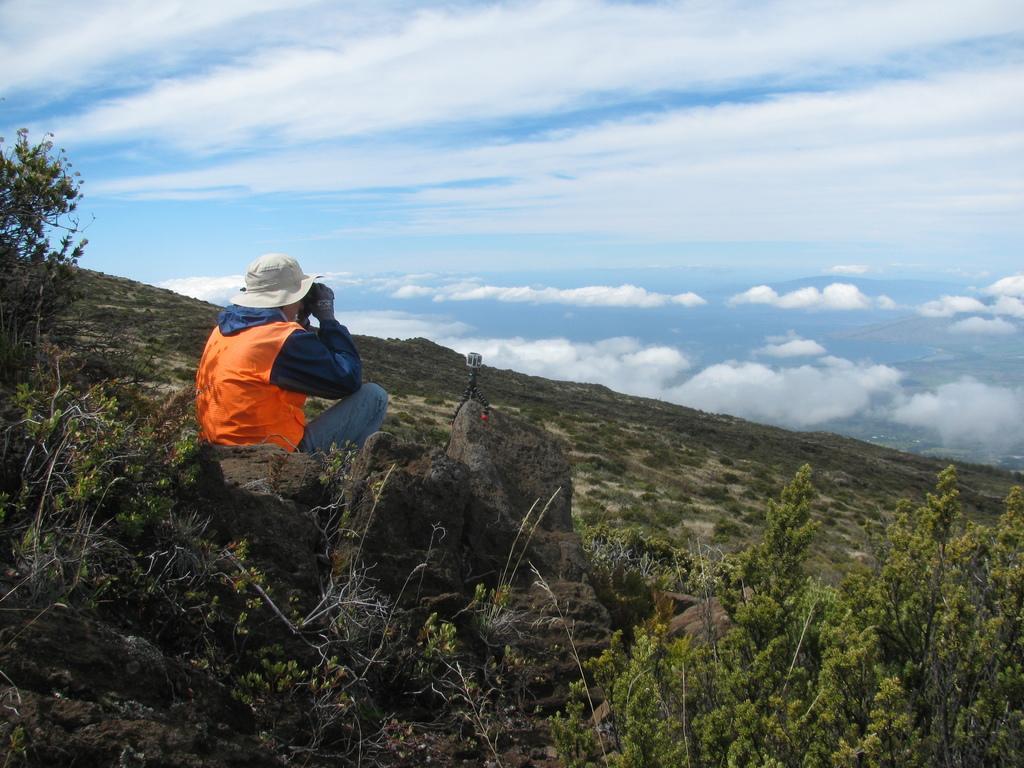How would you summarize this image in a sentence or two? In front of the image there are plants and rocks. There is a person sitting on the rock by holding some object. In front of him there is some object on the rock. At the top of the image there are clouds in the sky. 